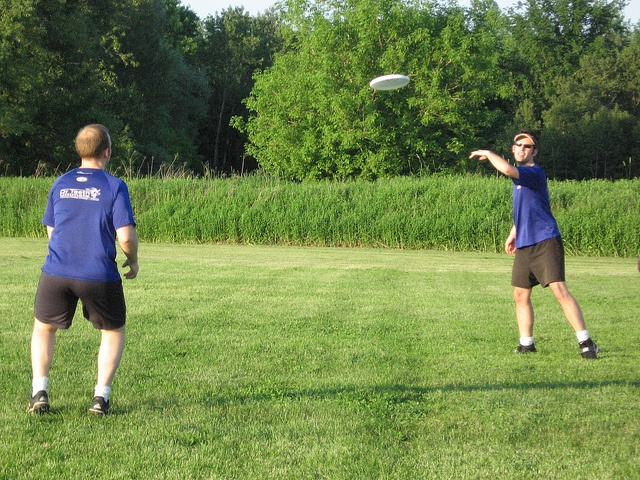Describe the objects in this image and their specific colors. I can see people in darkgreen, blue, black, gray, and ivory tones, people in darkgreen, gray, navy, blue, and tan tones, and frisbee in darkgreen, darkgray, white, and gray tones in this image. 